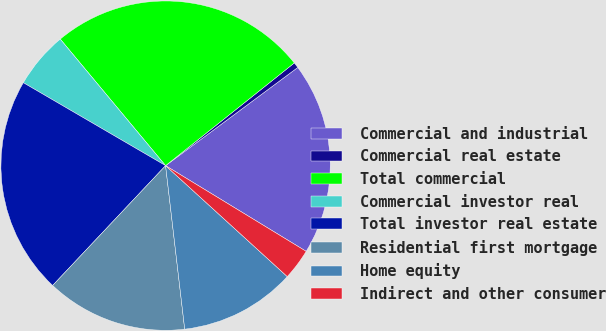Convert chart. <chart><loc_0><loc_0><loc_500><loc_500><pie_chart><fcel>Commercial and industrial<fcel>Commercial real estate<fcel>Total commercial<fcel>Commercial investor real<fcel>Total investor real estate<fcel>Residential first mortgage<fcel>Home equity<fcel>Indirect and other consumer<nl><fcel>18.88%<fcel>0.55%<fcel>25.33%<fcel>5.55%<fcel>21.37%<fcel>13.88%<fcel>11.38%<fcel>3.05%<nl></chart> 